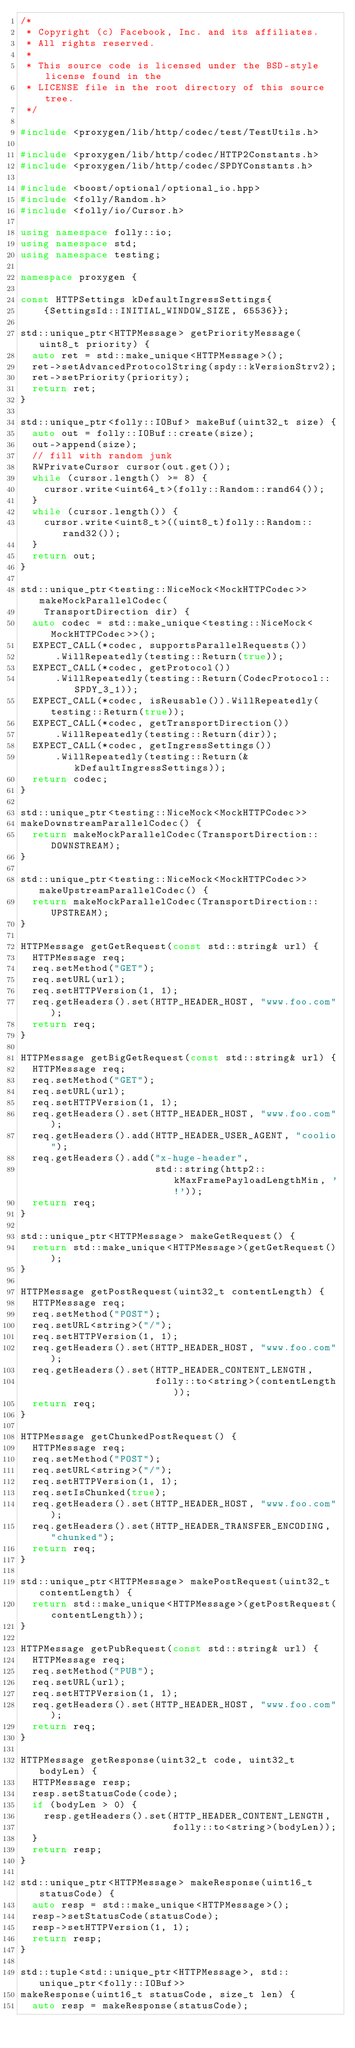Convert code to text. <code><loc_0><loc_0><loc_500><loc_500><_C++_>/*
 * Copyright (c) Facebook, Inc. and its affiliates.
 * All rights reserved.
 *
 * This source code is licensed under the BSD-style license found in the
 * LICENSE file in the root directory of this source tree.
 */

#include <proxygen/lib/http/codec/test/TestUtils.h>

#include <proxygen/lib/http/codec/HTTP2Constants.h>
#include <proxygen/lib/http/codec/SPDYConstants.h>

#include <boost/optional/optional_io.hpp>
#include <folly/Random.h>
#include <folly/io/Cursor.h>

using namespace folly::io;
using namespace std;
using namespace testing;

namespace proxygen {

const HTTPSettings kDefaultIngressSettings{
    {SettingsId::INITIAL_WINDOW_SIZE, 65536}};

std::unique_ptr<HTTPMessage> getPriorityMessage(uint8_t priority) {
  auto ret = std::make_unique<HTTPMessage>();
  ret->setAdvancedProtocolString(spdy::kVersionStrv2);
  ret->setPriority(priority);
  return ret;
}

std::unique_ptr<folly::IOBuf> makeBuf(uint32_t size) {
  auto out = folly::IOBuf::create(size);
  out->append(size);
  // fill with random junk
  RWPrivateCursor cursor(out.get());
  while (cursor.length() >= 8) {
    cursor.write<uint64_t>(folly::Random::rand64());
  }
  while (cursor.length()) {
    cursor.write<uint8_t>((uint8_t)folly::Random::rand32());
  }
  return out;
}

std::unique_ptr<testing::NiceMock<MockHTTPCodec>> makeMockParallelCodec(
    TransportDirection dir) {
  auto codec = std::make_unique<testing::NiceMock<MockHTTPCodec>>();
  EXPECT_CALL(*codec, supportsParallelRequests())
      .WillRepeatedly(testing::Return(true));
  EXPECT_CALL(*codec, getProtocol())
      .WillRepeatedly(testing::Return(CodecProtocol::SPDY_3_1));
  EXPECT_CALL(*codec, isReusable()).WillRepeatedly(testing::Return(true));
  EXPECT_CALL(*codec, getTransportDirection())
      .WillRepeatedly(testing::Return(dir));
  EXPECT_CALL(*codec, getIngressSettings())
      .WillRepeatedly(testing::Return(&kDefaultIngressSettings));
  return codec;
}

std::unique_ptr<testing::NiceMock<MockHTTPCodec>>
makeDownstreamParallelCodec() {
  return makeMockParallelCodec(TransportDirection::DOWNSTREAM);
}

std::unique_ptr<testing::NiceMock<MockHTTPCodec>> makeUpstreamParallelCodec() {
  return makeMockParallelCodec(TransportDirection::UPSTREAM);
}

HTTPMessage getGetRequest(const std::string& url) {
  HTTPMessage req;
  req.setMethod("GET");
  req.setURL(url);
  req.setHTTPVersion(1, 1);
  req.getHeaders().set(HTTP_HEADER_HOST, "www.foo.com");
  return req;
}

HTTPMessage getBigGetRequest(const std::string& url) {
  HTTPMessage req;
  req.setMethod("GET");
  req.setURL(url);
  req.setHTTPVersion(1, 1);
  req.getHeaders().set(HTTP_HEADER_HOST, "www.foo.com");
  req.getHeaders().add(HTTP_HEADER_USER_AGENT, "coolio");
  req.getHeaders().add("x-huge-header",
                       std::string(http2::kMaxFramePayloadLengthMin, '!'));
  return req;
}

std::unique_ptr<HTTPMessage> makeGetRequest() {
  return std::make_unique<HTTPMessage>(getGetRequest());
}

HTTPMessage getPostRequest(uint32_t contentLength) {
  HTTPMessage req;
  req.setMethod("POST");
  req.setURL<string>("/");
  req.setHTTPVersion(1, 1);
  req.getHeaders().set(HTTP_HEADER_HOST, "www.foo.com");
  req.getHeaders().set(HTTP_HEADER_CONTENT_LENGTH,
                       folly::to<string>(contentLength));
  return req;
}

HTTPMessage getChunkedPostRequest() {
  HTTPMessage req;
  req.setMethod("POST");
  req.setURL<string>("/");
  req.setHTTPVersion(1, 1);
  req.setIsChunked(true);
  req.getHeaders().set(HTTP_HEADER_HOST, "www.foo.com");
  req.getHeaders().set(HTTP_HEADER_TRANSFER_ENCODING, "chunked");
  return req;
}

std::unique_ptr<HTTPMessage> makePostRequest(uint32_t contentLength) {
  return std::make_unique<HTTPMessage>(getPostRequest(contentLength));
}

HTTPMessage getPubRequest(const std::string& url) {
  HTTPMessage req;
  req.setMethod("PUB");
  req.setURL(url);
  req.setHTTPVersion(1, 1);
  req.getHeaders().set(HTTP_HEADER_HOST, "www.foo.com");
  return req;
}

HTTPMessage getResponse(uint32_t code, uint32_t bodyLen) {
  HTTPMessage resp;
  resp.setStatusCode(code);
  if (bodyLen > 0) {
    resp.getHeaders().set(HTTP_HEADER_CONTENT_LENGTH,
                          folly::to<string>(bodyLen));
  }
  return resp;
}

std::unique_ptr<HTTPMessage> makeResponse(uint16_t statusCode) {
  auto resp = std::make_unique<HTTPMessage>();
  resp->setStatusCode(statusCode);
  resp->setHTTPVersion(1, 1);
  return resp;
}

std::tuple<std::unique_ptr<HTTPMessage>, std::unique_ptr<folly::IOBuf>>
makeResponse(uint16_t statusCode, size_t len) {
  auto resp = makeResponse(statusCode);</code> 